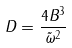<formula> <loc_0><loc_0><loc_500><loc_500>D = \frac { 4 B ^ { 3 } } { \tilde { \omega } ^ { 2 } }</formula> 